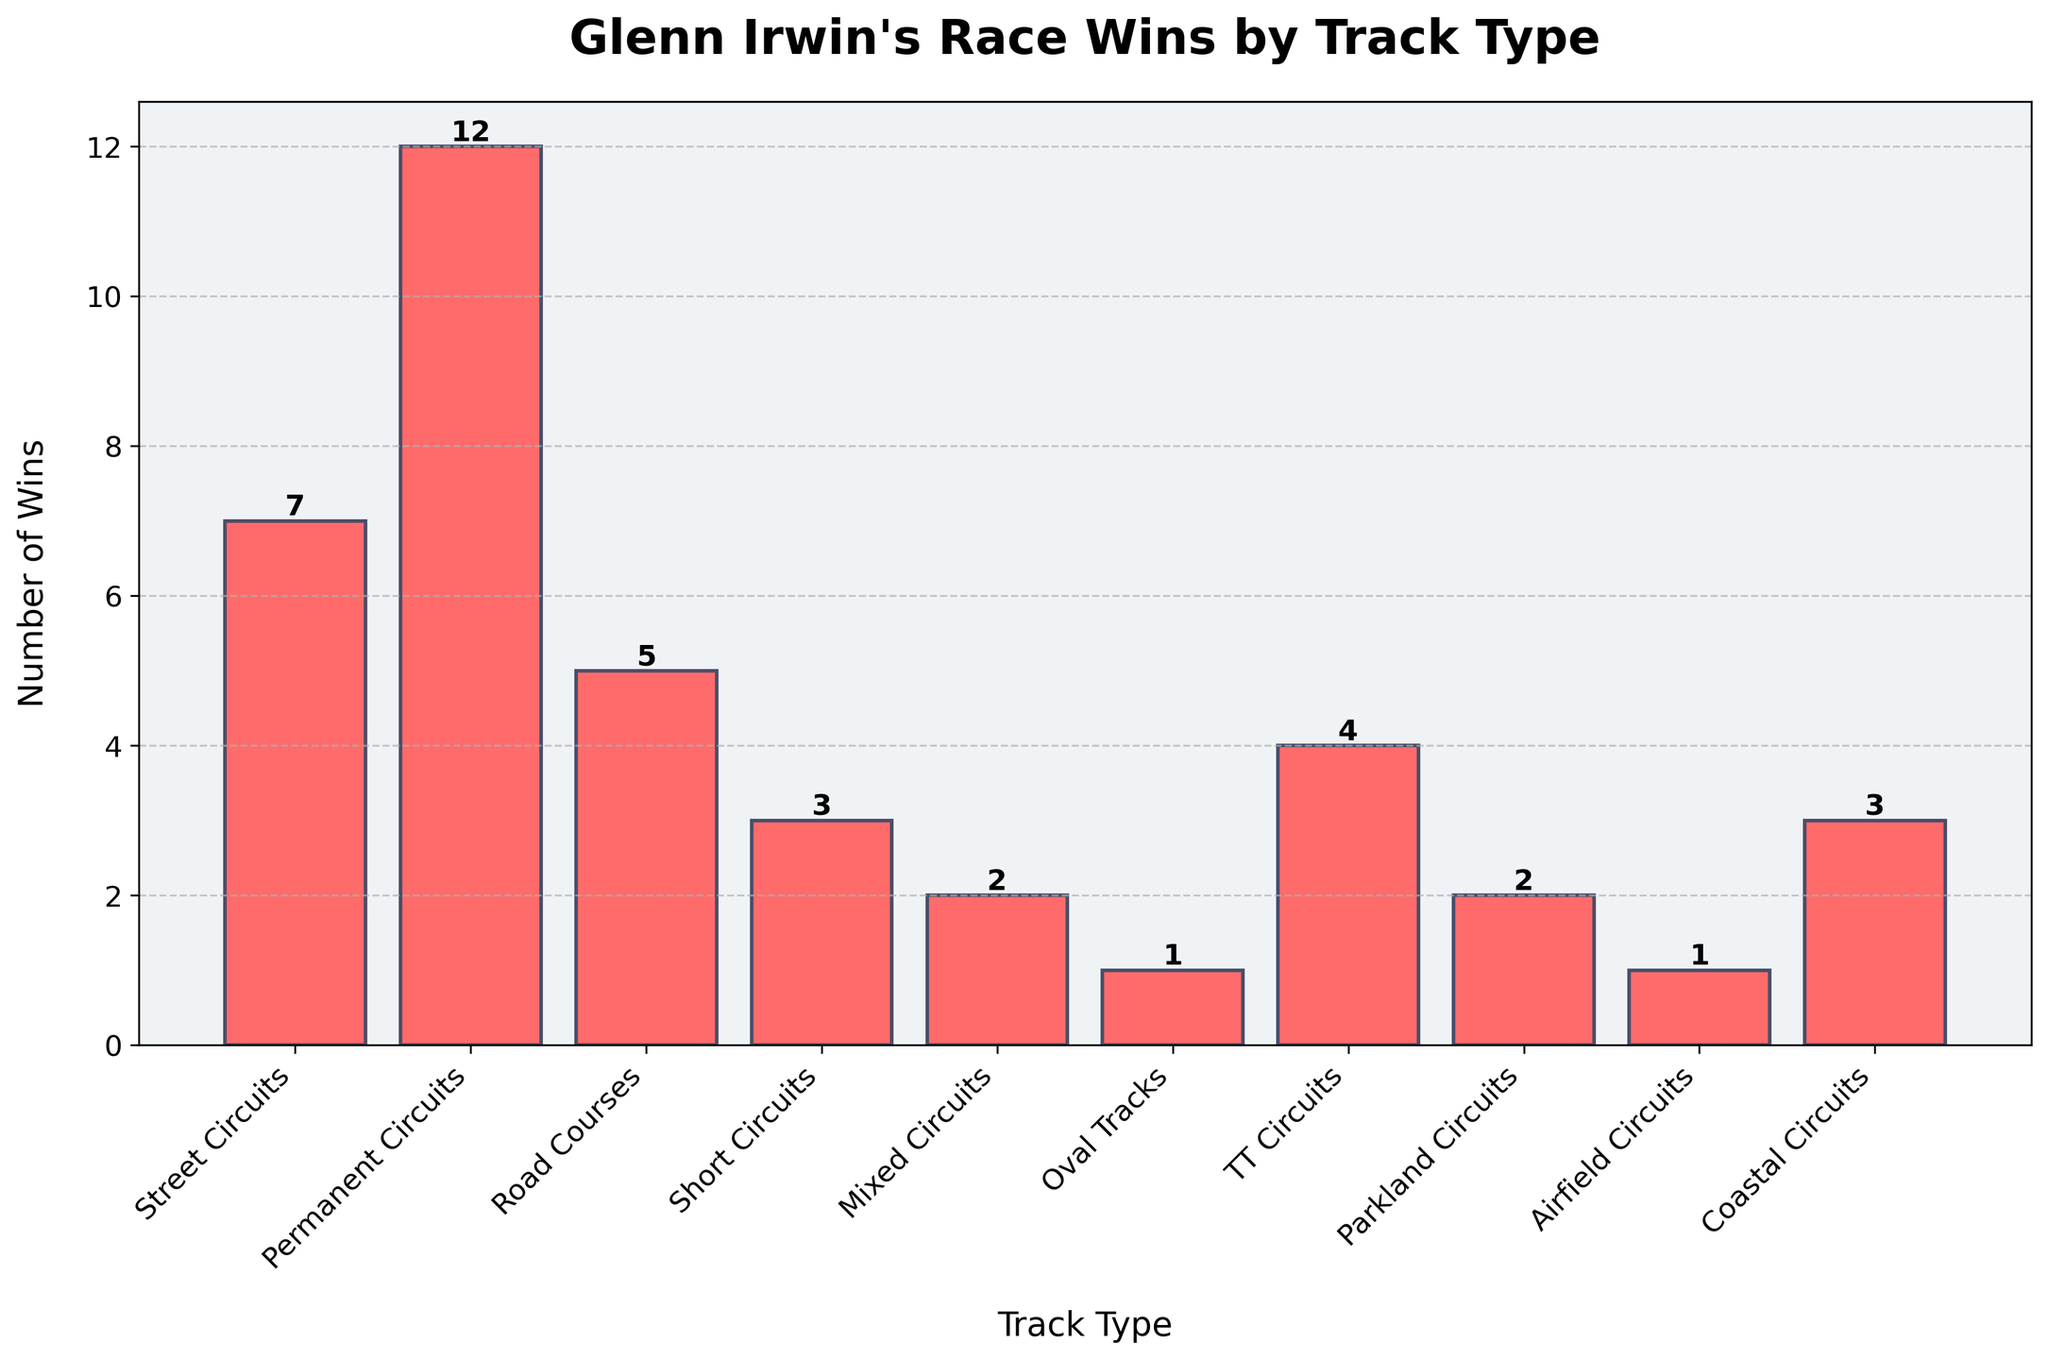What is the total number of wins Glenn Irwin has on street circuits and permanent circuits? Sum the wins for street circuits (7) and permanent circuits (12). 7 + 12 = 19
Answer: 19 Which track type has the highest number of race wins for Glenn Irwin? Identify the track type with the tallest bar in the chart; the tallest bar represents permanent circuits with 12 wins
Answer: Permanent Circuits How many more wins does Glenn Irwin have on road courses than on short circuits? Subtract the number of wins on short circuits (3) from the number of wins on road courses (5). 5 - 3 = 2
Answer: 2 On which track types does Glenn Irwin have exactly 3 wins? Identify the track types with bars corresponding to the number 3; these are short circuits and coastal circuits
Answer: Short Circuits, Coastal Circuits What is the sum of race wins across street circuits, short circuits, and TT circuits? Add the number of wins for street circuits (7), short circuits (3), and TT circuits (4). 7 + 3 + 4 = 14
Answer: 14 Which track type has the lowest number of race wins for Glenn Irwin, and how many wins are they? Identify the track type with the shortest bar in the chart; this is oval tracks with 1 win
Answer: Oval Tracks, 1 Does Glenn Irwin have more wins on mixed circuits or parkland circuits, and by how many? Compare the wins on mixed circuits (2) and parkland circuits (2) by seeing which bars are longer, they are equal
Answer: Equal, 0 Which track types have fewer wins than road courses? Identify all bar lengths that are shorter than the bar for road courses (5); these include short circuits (3), mixed circuits (2), oval tracks (1), TT circuits (4), parkland circuits (2), airfield circuits (1), and coastal circuits (3)
Answer: Short Circuits, Mixed Circuits, Oval Tracks, TT Circuits, Parkland Circuits, Airfield Circuits, Coastal Circuits If you combine wins on permanent circuits and coastal circuits, do they exceed the sum of wins on TT circuits and road courses? Calculate the sum of wins on permanent circuits (12) and coastal circuits (3), which equals 15. Then calculate the sum for TT circuits (4) and road courses (5), which equals 9. Compare the two sums, 15 > 9
Answer: Yes Which track types have exactly two wins, and how can you identify them in the chart? Locate the bars that have a height corresponding to the number 2; these are mixed circuits and parkland circuits
Answer: Mixed Circuits, Parkland Circuits 